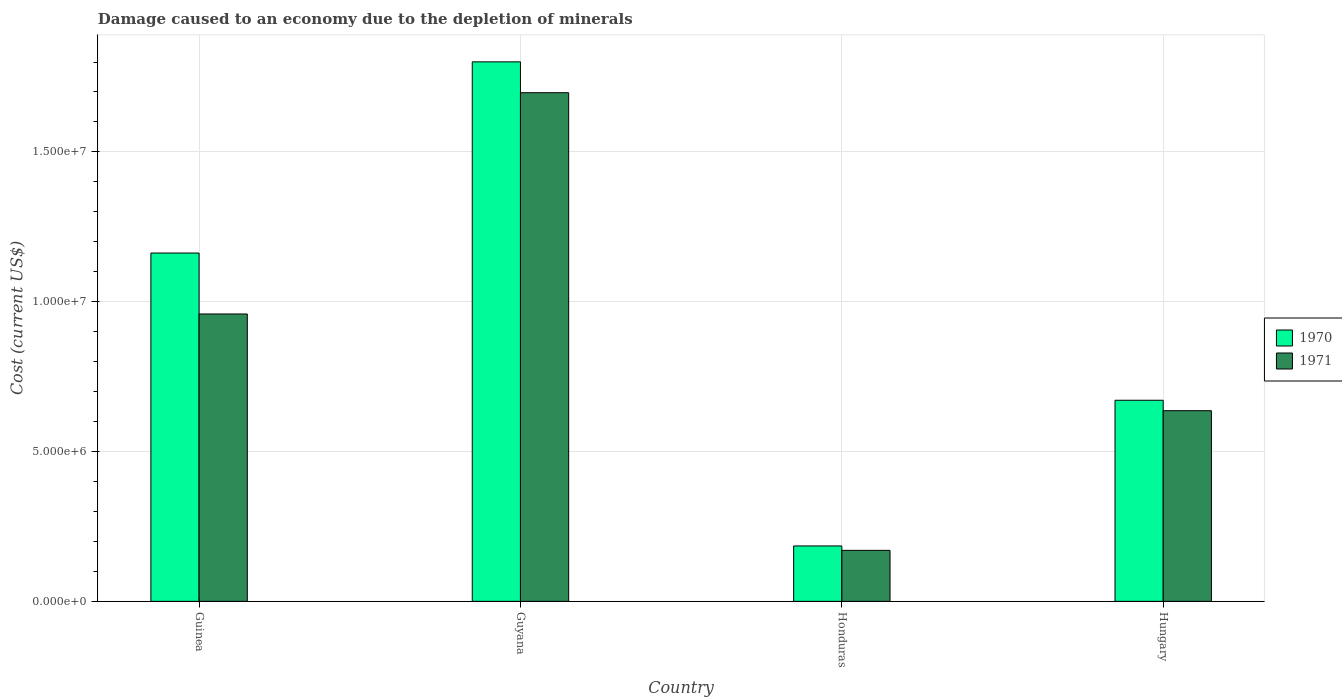How many bars are there on the 3rd tick from the right?
Ensure brevity in your answer.  2. What is the label of the 3rd group of bars from the left?
Your response must be concise. Honduras. In how many cases, is the number of bars for a given country not equal to the number of legend labels?
Make the answer very short. 0. What is the cost of damage caused due to the depletion of minerals in 1971 in Hungary?
Offer a very short reply. 6.36e+06. Across all countries, what is the maximum cost of damage caused due to the depletion of minerals in 1970?
Keep it short and to the point. 1.80e+07. Across all countries, what is the minimum cost of damage caused due to the depletion of minerals in 1971?
Provide a short and direct response. 1.70e+06. In which country was the cost of damage caused due to the depletion of minerals in 1970 maximum?
Provide a short and direct response. Guyana. In which country was the cost of damage caused due to the depletion of minerals in 1970 minimum?
Your answer should be compact. Honduras. What is the total cost of damage caused due to the depletion of minerals in 1970 in the graph?
Give a very brief answer. 3.82e+07. What is the difference between the cost of damage caused due to the depletion of minerals in 1970 in Guinea and that in Honduras?
Your answer should be compact. 9.78e+06. What is the difference between the cost of damage caused due to the depletion of minerals in 1970 in Hungary and the cost of damage caused due to the depletion of minerals in 1971 in Guyana?
Make the answer very short. -1.03e+07. What is the average cost of damage caused due to the depletion of minerals in 1970 per country?
Your answer should be very brief. 9.55e+06. What is the difference between the cost of damage caused due to the depletion of minerals of/in 1970 and cost of damage caused due to the depletion of minerals of/in 1971 in Guyana?
Offer a very short reply. 1.03e+06. What is the ratio of the cost of damage caused due to the depletion of minerals in 1971 in Guinea to that in Hungary?
Offer a very short reply. 1.51. Is the cost of damage caused due to the depletion of minerals in 1970 in Guyana less than that in Hungary?
Keep it short and to the point. No. Is the difference between the cost of damage caused due to the depletion of minerals in 1970 in Guyana and Hungary greater than the difference between the cost of damage caused due to the depletion of minerals in 1971 in Guyana and Hungary?
Give a very brief answer. Yes. What is the difference between the highest and the second highest cost of damage caused due to the depletion of minerals in 1971?
Provide a succinct answer. 1.06e+07. What is the difference between the highest and the lowest cost of damage caused due to the depletion of minerals in 1970?
Your answer should be very brief. 1.62e+07. In how many countries, is the cost of damage caused due to the depletion of minerals in 1970 greater than the average cost of damage caused due to the depletion of minerals in 1970 taken over all countries?
Your response must be concise. 2. Is the sum of the cost of damage caused due to the depletion of minerals in 1971 in Guinea and Guyana greater than the maximum cost of damage caused due to the depletion of minerals in 1970 across all countries?
Provide a succinct answer. Yes. How many bars are there?
Ensure brevity in your answer.  8. Are all the bars in the graph horizontal?
Your answer should be compact. No. How many countries are there in the graph?
Make the answer very short. 4. What is the difference between two consecutive major ticks on the Y-axis?
Offer a very short reply. 5.00e+06. Are the values on the major ticks of Y-axis written in scientific E-notation?
Offer a terse response. Yes. Does the graph contain any zero values?
Offer a terse response. No. How many legend labels are there?
Your answer should be compact. 2. What is the title of the graph?
Offer a terse response. Damage caused to an economy due to the depletion of minerals. What is the label or title of the X-axis?
Ensure brevity in your answer.  Country. What is the label or title of the Y-axis?
Your response must be concise. Cost (current US$). What is the Cost (current US$) of 1970 in Guinea?
Make the answer very short. 1.16e+07. What is the Cost (current US$) in 1971 in Guinea?
Your response must be concise. 9.59e+06. What is the Cost (current US$) in 1970 in Guyana?
Keep it short and to the point. 1.80e+07. What is the Cost (current US$) of 1971 in Guyana?
Make the answer very short. 1.70e+07. What is the Cost (current US$) of 1970 in Honduras?
Your response must be concise. 1.85e+06. What is the Cost (current US$) in 1971 in Honduras?
Provide a short and direct response. 1.70e+06. What is the Cost (current US$) in 1970 in Hungary?
Provide a short and direct response. 6.71e+06. What is the Cost (current US$) in 1971 in Hungary?
Offer a terse response. 6.36e+06. Across all countries, what is the maximum Cost (current US$) of 1970?
Ensure brevity in your answer.  1.80e+07. Across all countries, what is the maximum Cost (current US$) in 1971?
Provide a short and direct response. 1.70e+07. Across all countries, what is the minimum Cost (current US$) of 1970?
Make the answer very short. 1.85e+06. Across all countries, what is the minimum Cost (current US$) of 1971?
Make the answer very short. 1.70e+06. What is the total Cost (current US$) of 1970 in the graph?
Your answer should be very brief. 3.82e+07. What is the total Cost (current US$) of 1971 in the graph?
Provide a short and direct response. 3.46e+07. What is the difference between the Cost (current US$) of 1970 in Guinea and that in Guyana?
Your answer should be very brief. -6.38e+06. What is the difference between the Cost (current US$) in 1971 in Guinea and that in Guyana?
Your answer should be compact. -7.38e+06. What is the difference between the Cost (current US$) in 1970 in Guinea and that in Honduras?
Give a very brief answer. 9.78e+06. What is the difference between the Cost (current US$) of 1971 in Guinea and that in Honduras?
Keep it short and to the point. 7.89e+06. What is the difference between the Cost (current US$) in 1970 in Guinea and that in Hungary?
Your answer should be compact. 4.91e+06. What is the difference between the Cost (current US$) of 1971 in Guinea and that in Hungary?
Keep it short and to the point. 3.23e+06. What is the difference between the Cost (current US$) of 1970 in Guyana and that in Honduras?
Ensure brevity in your answer.  1.62e+07. What is the difference between the Cost (current US$) of 1971 in Guyana and that in Honduras?
Ensure brevity in your answer.  1.53e+07. What is the difference between the Cost (current US$) of 1970 in Guyana and that in Hungary?
Offer a very short reply. 1.13e+07. What is the difference between the Cost (current US$) in 1971 in Guyana and that in Hungary?
Provide a succinct answer. 1.06e+07. What is the difference between the Cost (current US$) in 1970 in Honduras and that in Hungary?
Keep it short and to the point. -4.86e+06. What is the difference between the Cost (current US$) in 1971 in Honduras and that in Hungary?
Ensure brevity in your answer.  -4.66e+06. What is the difference between the Cost (current US$) in 1970 in Guinea and the Cost (current US$) in 1971 in Guyana?
Ensure brevity in your answer.  -5.35e+06. What is the difference between the Cost (current US$) of 1970 in Guinea and the Cost (current US$) of 1971 in Honduras?
Your answer should be compact. 9.92e+06. What is the difference between the Cost (current US$) of 1970 in Guinea and the Cost (current US$) of 1971 in Hungary?
Provide a short and direct response. 5.26e+06. What is the difference between the Cost (current US$) of 1970 in Guyana and the Cost (current US$) of 1971 in Honduras?
Offer a very short reply. 1.63e+07. What is the difference between the Cost (current US$) in 1970 in Guyana and the Cost (current US$) in 1971 in Hungary?
Give a very brief answer. 1.16e+07. What is the difference between the Cost (current US$) in 1970 in Honduras and the Cost (current US$) in 1971 in Hungary?
Give a very brief answer. -4.51e+06. What is the average Cost (current US$) of 1970 per country?
Keep it short and to the point. 9.55e+06. What is the average Cost (current US$) in 1971 per country?
Your answer should be compact. 8.66e+06. What is the difference between the Cost (current US$) in 1970 and Cost (current US$) in 1971 in Guinea?
Provide a succinct answer. 2.03e+06. What is the difference between the Cost (current US$) of 1970 and Cost (current US$) of 1971 in Guyana?
Your answer should be compact. 1.03e+06. What is the difference between the Cost (current US$) in 1970 and Cost (current US$) in 1971 in Honduras?
Your response must be concise. 1.47e+05. What is the difference between the Cost (current US$) in 1970 and Cost (current US$) in 1971 in Hungary?
Your answer should be very brief. 3.48e+05. What is the ratio of the Cost (current US$) in 1970 in Guinea to that in Guyana?
Your response must be concise. 0.65. What is the ratio of the Cost (current US$) of 1971 in Guinea to that in Guyana?
Give a very brief answer. 0.56. What is the ratio of the Cost (current US$) in 1970 in Guinea to that in Honduras?
Keep it short and to the point. 6.29. What is the ratio of the Cost (current US$) of 1971 in Guinea to that in Honduras?
Your response must be concise. 5.63. What is the ratio of the Cost (current US$) of 1970 in Guinea to that in Hungary?
Provide a succinct answer. 1.73. What is the ratio of the Cost (current US$) of 1971 in Guinea to that in Hungary?
Your response must be concise. 1.51. What is the ratio of the Cost (current US$) in 1970 in Guyana to that in Honduras?
Your answer should be compact. 9.74. What is the ratio of the Cost (current US$) in 1971 in Guyana to that in Honduras?
Provide a short and direct response. 9.97. What is the ratio of the Cost (current US$) of 1970 in Guyana to that in Hungary?
Your answer should be very brief. 2.68. What is the ratio of the Cost (current US$) in 1971 in Guyana to that in Hungary?
Make the answer very short. 2.67. What is the ratio of the Cost (current US$) in 1970 in Honduras to that in Hungary?
Make the answer very short. 0.28. What is the ratio of the Cost (current US$) in 1971 in Honduras to that in Hungary?
Provide a succinct answer. 0.27. What is the difference between the highest and the second highest Cost (current US$) in 1970?
Ensure brevity in your answer.  6.38e+06. What is the difference between the highest and the second highest Cost (current US$) in 1971?
Ensure brevity in your answer.  7.38e+06. What is the difference between the highest and the lowest Cost (current US$) in 1970?
Provide a succinct answer. 1.62e+07. What is the difference between the highest and the lowest Cost (current US$) of 1971?
Give a very brief answer. 1.53e+07. 